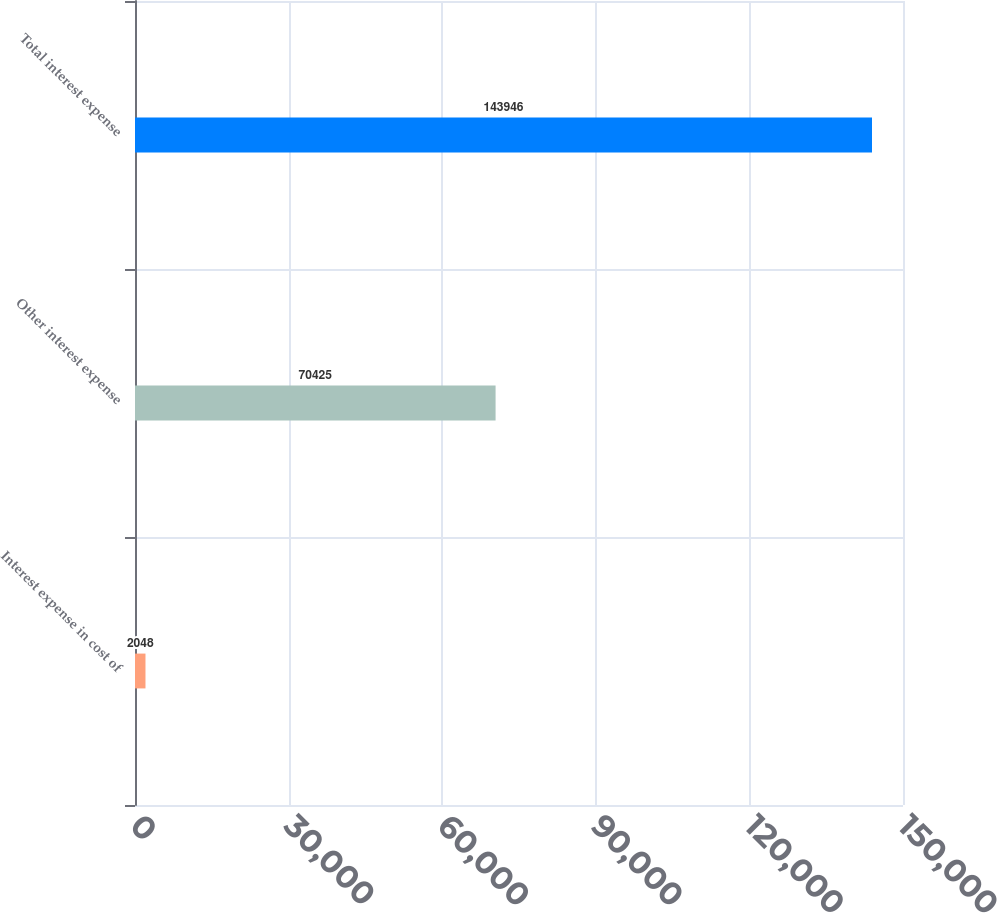Convert chart to OTSL. <chart><loc_0><loc_0><loc_500><loc_500><bar_chart><fcel>Interest expense in cost of<fcel>Other interest expense<fcel>Total interest expense<nl><fcel>2048<fcel>70425<fcel>143946<nl></chart> 